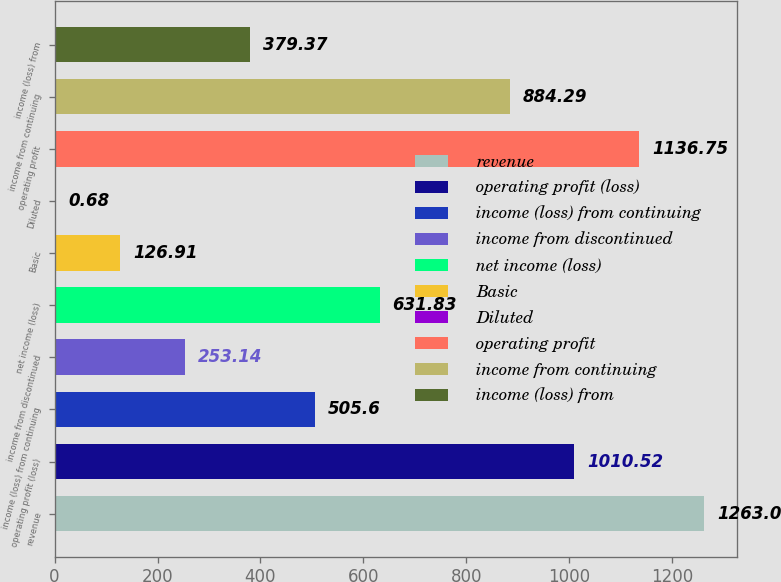<chart> <loc_0><loc_0><loc_500><loc_500><bar_chart><fcel>revenue<fcel>operating profit (loss)<fcel>income (loss) from continuing<fcel>income from discontinued<fcel>net income (loss)<fcel>Basic<fcel>Diluted<fcel>operating profit<fcel>income from continuing<fcel>income (loss) from<nl><fcel>1263<fcel>1010.52<fcel>505.6<fcel>253.14<fcel>631.83<fcel>126.91<fcel>0.68<fcel>1136.75<fcel>884.29<fcel>379.37<nl></chart> 